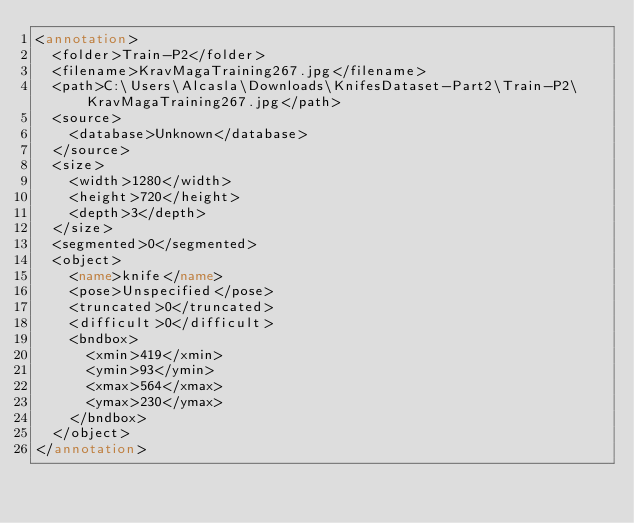<code> <loc_0><loc_0><loc_500><loc_500><_XML_><annotation>
	<folder>Train-P2</folder>
	<filename>KravMagaTraining267.jpg</filename>
	<path>C:\Users\Alcasla\Downloads\KnifesDataset-Part2\Train-P2\KravMagaTraining267.jpg</path>
	<source>
		<database>Unknown</database>
	</source>
	<size>
		<width>1280</width>
		<height>720</height>
		<depth>3</depth>
	</size>
	<segmented>0</segmented>
	<object>
		<name>knife</name>
		<pose>Unspecified</pose>
		<truncated>0</truncated>
		<difficult>0</difficult>
		<bndbox>
			<xmin>419</xmin>
			<ymin>93</ymin>
			<xmax>564</xmax>
			<ymax>230</ymax>
		</bndbox>
	</object>
</annotation>
</code> 